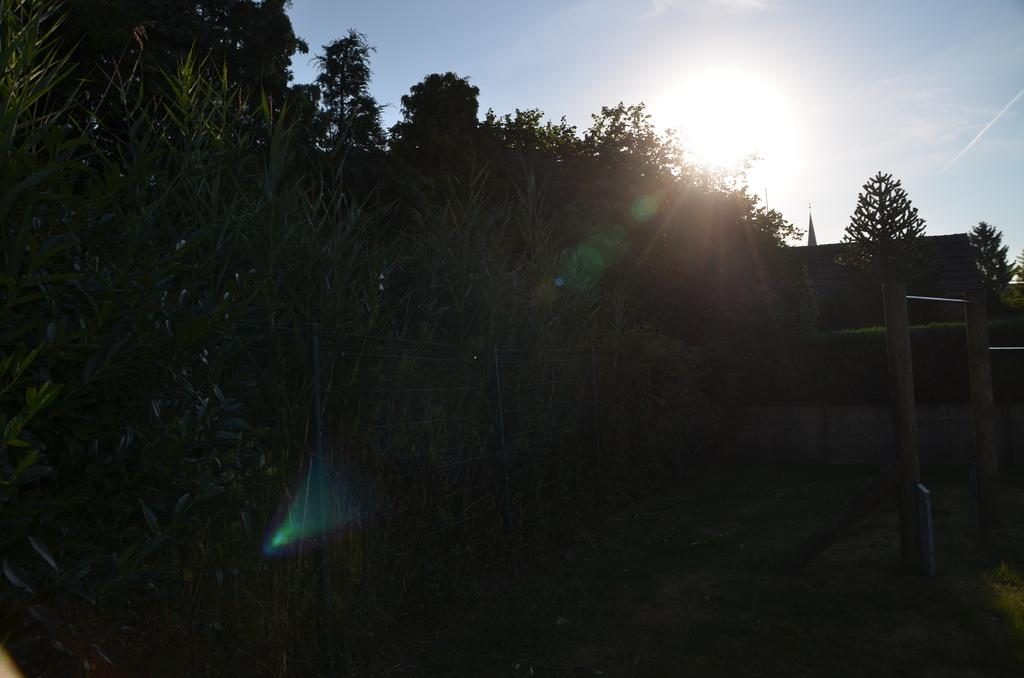What type of vegetation can be seen in the image? There are trees in the image. What type of structure is present in the image? There is a house in the image. What can be seen in the sky in the image? Sunlight is visible in the sky. What type of vertical structures are in the image? There are poles in the image. What type of gold object is hanging from the trees in the image? There is no gold object present in the image; it only features trees, a house, sunlight, and poles. What type of pollution can be seen in the image? There is no pollution visible in the image. 